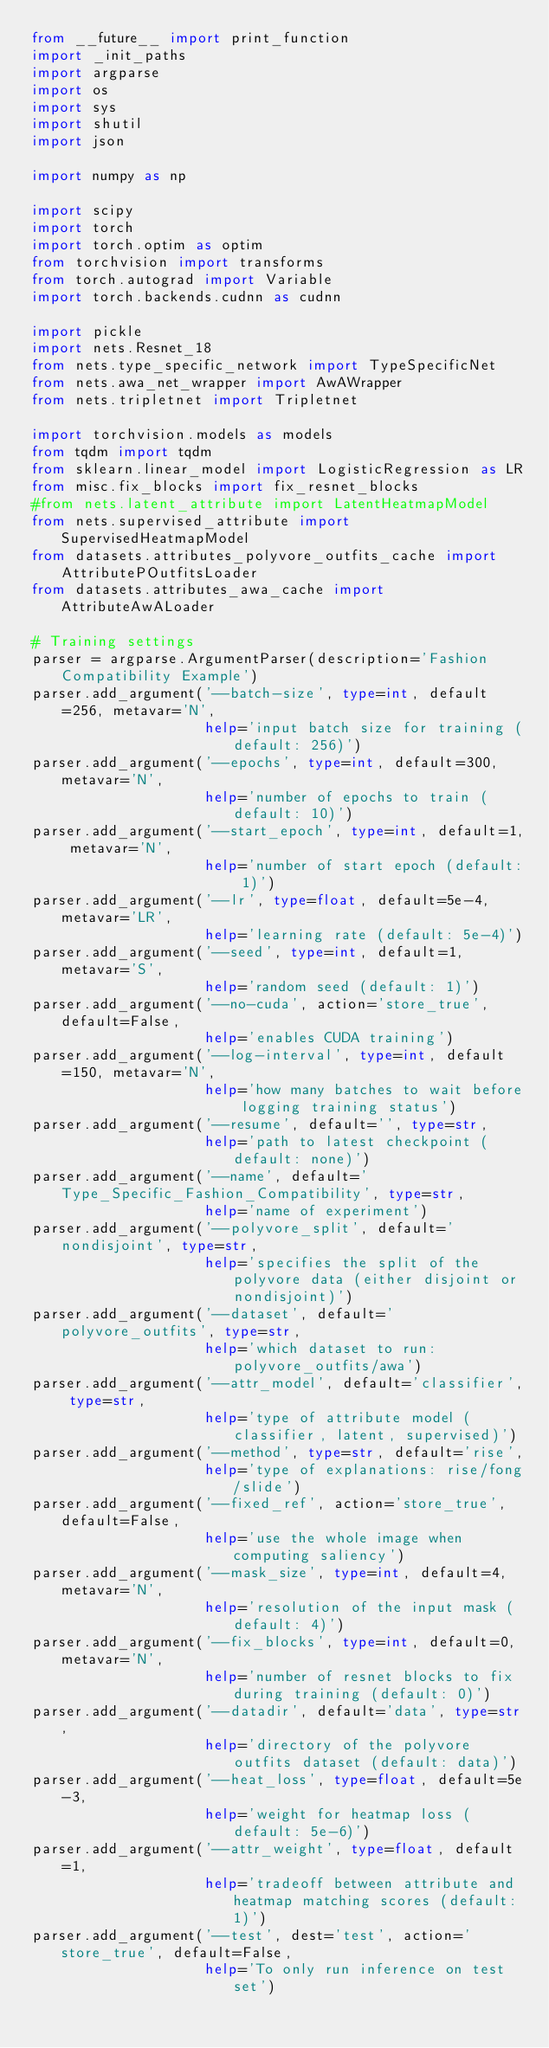Convert code to text. <code><loc_0><loc_0><loc_500><loc_500><_Python_>from __future__ import print_function
import _init_paths
import argparse
import os
import sys
import shutil
import json

import numpy as np

import scipy
import torch
import torch.optim as optim
from torchvision import transforms
from torch.autograd import Variable
import torch.backends.cudnn as cudnn

import pickle
import nets.Resnet_18
from nets.type_specific_network import TypeSpecificNet
from nets.awa_net_wrapper import AwAWrapper
from nets.tripletnet import Tripletnet

import torchvision.models as models
from tqdm import tqdm
from sklearn.linear_model import LogisticRegression as LR
from misc.fix_blocks import fix_resnet_blocks
#from nets.latent_attribute import LatentHeatmapModel
from nets.supervised_attribute import SupervisedHeatmapModel
from datasets.attributes_polyvore_outfits_cache import AttributePOutfitsLoader
from datasets.attributes_awa_cache import AttributeAwALoader

# Training settings
parser = argparse.ArgumentParser(description='Fashion Compatibility Example')
parser.add_argument('--batch-size', type=int, default=256, metavar='N',
                    help='input batch size for training (default: 256)')
parser.add_argument('--epochs', type=int, default=300, metavar='N',
                    help='number of epochs to train (default: 10)')
parser.add_argument('--start_epoch', type=int, default=1, metavar='N',
                    help='number of start epoch (default: 1)')
parser.add_argument('--lr', type=float, default=5e-4, metavar='LR',
                    help='learning rate (default: 5e-4)')
parser.add_argument('--seed', type=int, default=1, metavar='S',
                    help='random seed (default: 1)')
parser.add_argument('--no-cuda', action='store_true', default=False,
                    help='enables CUDA training')
parser.add_argument('--log-interval', type=int, default=150, metavar='N',
                    help='how many batches to wait before logging training status')
parser.add_argument('--resume', default='', type=str,
                    help='path to latest checkpoint (default: none)')
parser.add_argument('--name', default='Type_Specific_Fashion_Compatibility', type=str,
                    help='name of experiment')
parser.add_argument('--polyvore_split', default='nondisjoint', type=str,
                    help='specifies the split of the polyvore data (either disjoint or nondisjoint)')
parser.add_argument('--dataset', default='polyvore_outfits', type=str,
                    help='which dataset to run: polyvore_outfits/awa')
parser.add_argument('--attr_model', default='classifier', type=str,
                    help='type of attribute model (classifier, latent, supervised)')
parser.add_argument('--method', type=str, default='rise',
                    help='type of explanations: rise/fong/slide')
parser.add_argument('--fixed_ref', action='store_true', default=False,
                    help='use the whole image when computing saliency')
parser.add_argument('--mask_size', type=int, default=4, metavar='N',
                    help='resolution of the input mask (default: 4)')
parser.add_argument('--fix_blocks', type=int, default=0, metavar='N',
                    help='number of resnet blocks to fix during training (default: 0)')
parser.add_argument('--datadir', default='data', type=str,
                    help='directory of the polyvore outfits dataset (default: data)')
parser.add_argument('--heat_loss', type=float, default=5e-3,
                    help='weight for heatmap loss (default: 5e-6)')
parser.add_argument('--attr_weight', type=float, default=1,
                    help='tradeoff between attribute and heatmap matching scores (default: 1)')
parser.add_argument('--test', dest='test', action='store_true', default=False,
                    help='To only run inference on test set')</code> 